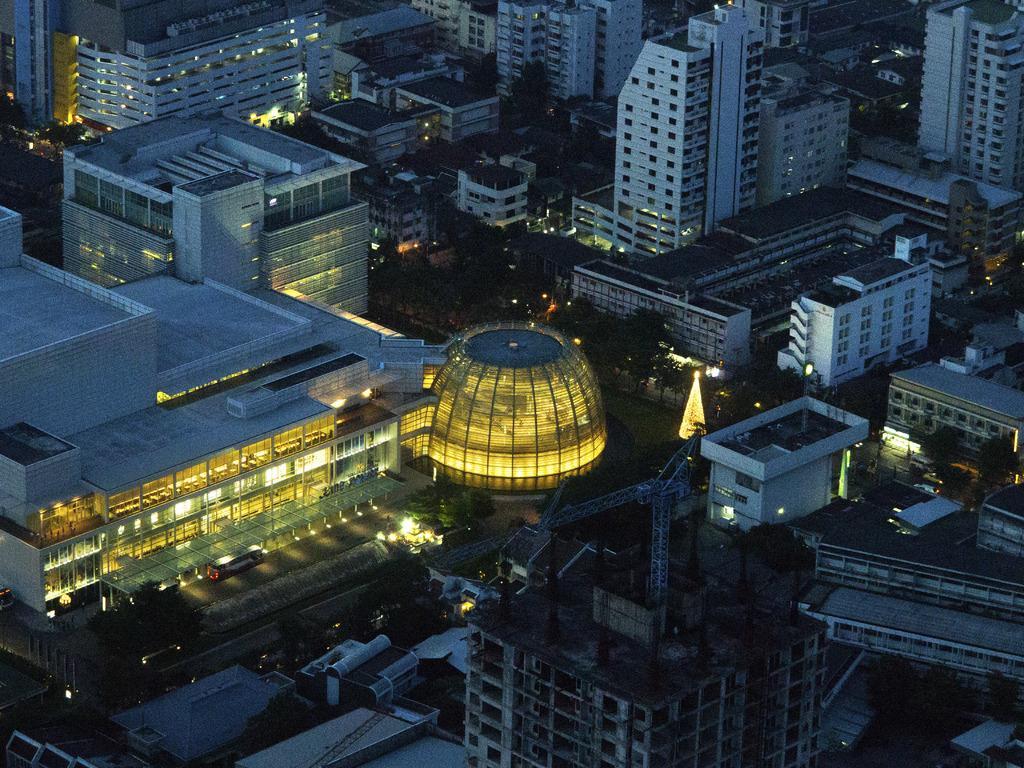In one or two sentences, can you explain what this image depicts? In this image, I can see the buildings and houses with the lights. I think these are the trees. This looks like a vehicle. I can see a tower crane, which is at the top of a building. 